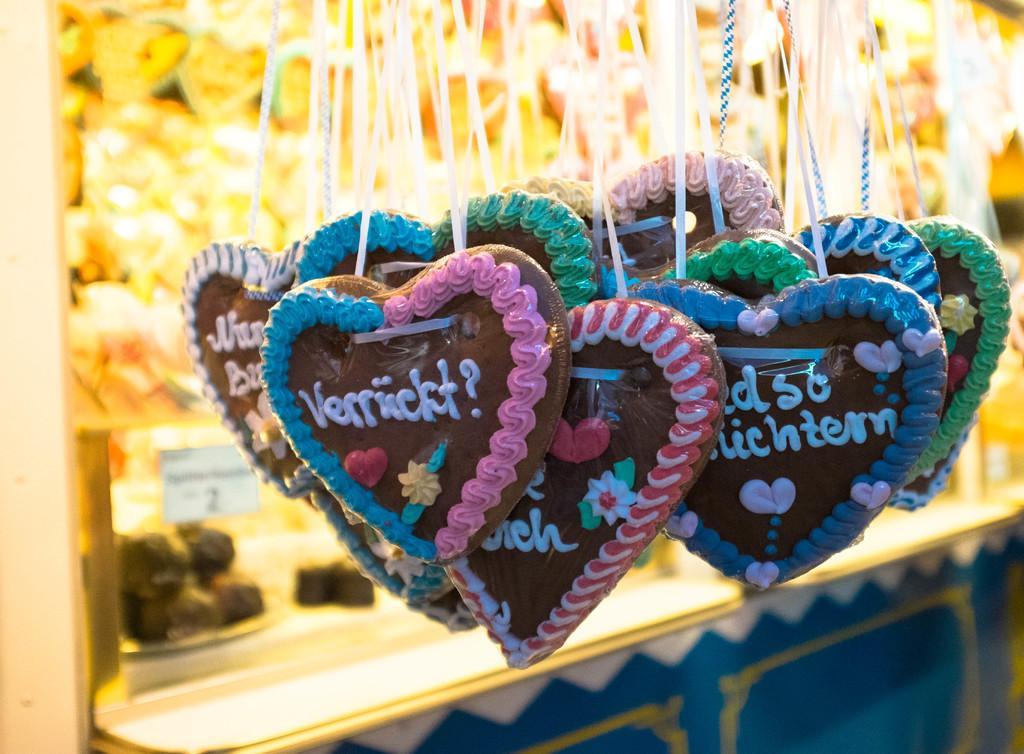What is the relationship between the objects in the image? There are objects hanging from another object in the image. What can be seen on the hanging objects? There is writing on the hanging objects. How would you describe the background of the image? The background of the image is blurred. How does the fog affect the visibility of the patch in the image? There is no fog or patch present in the image; it only features objects hanging from another object with writing on them, and a blurred background. 